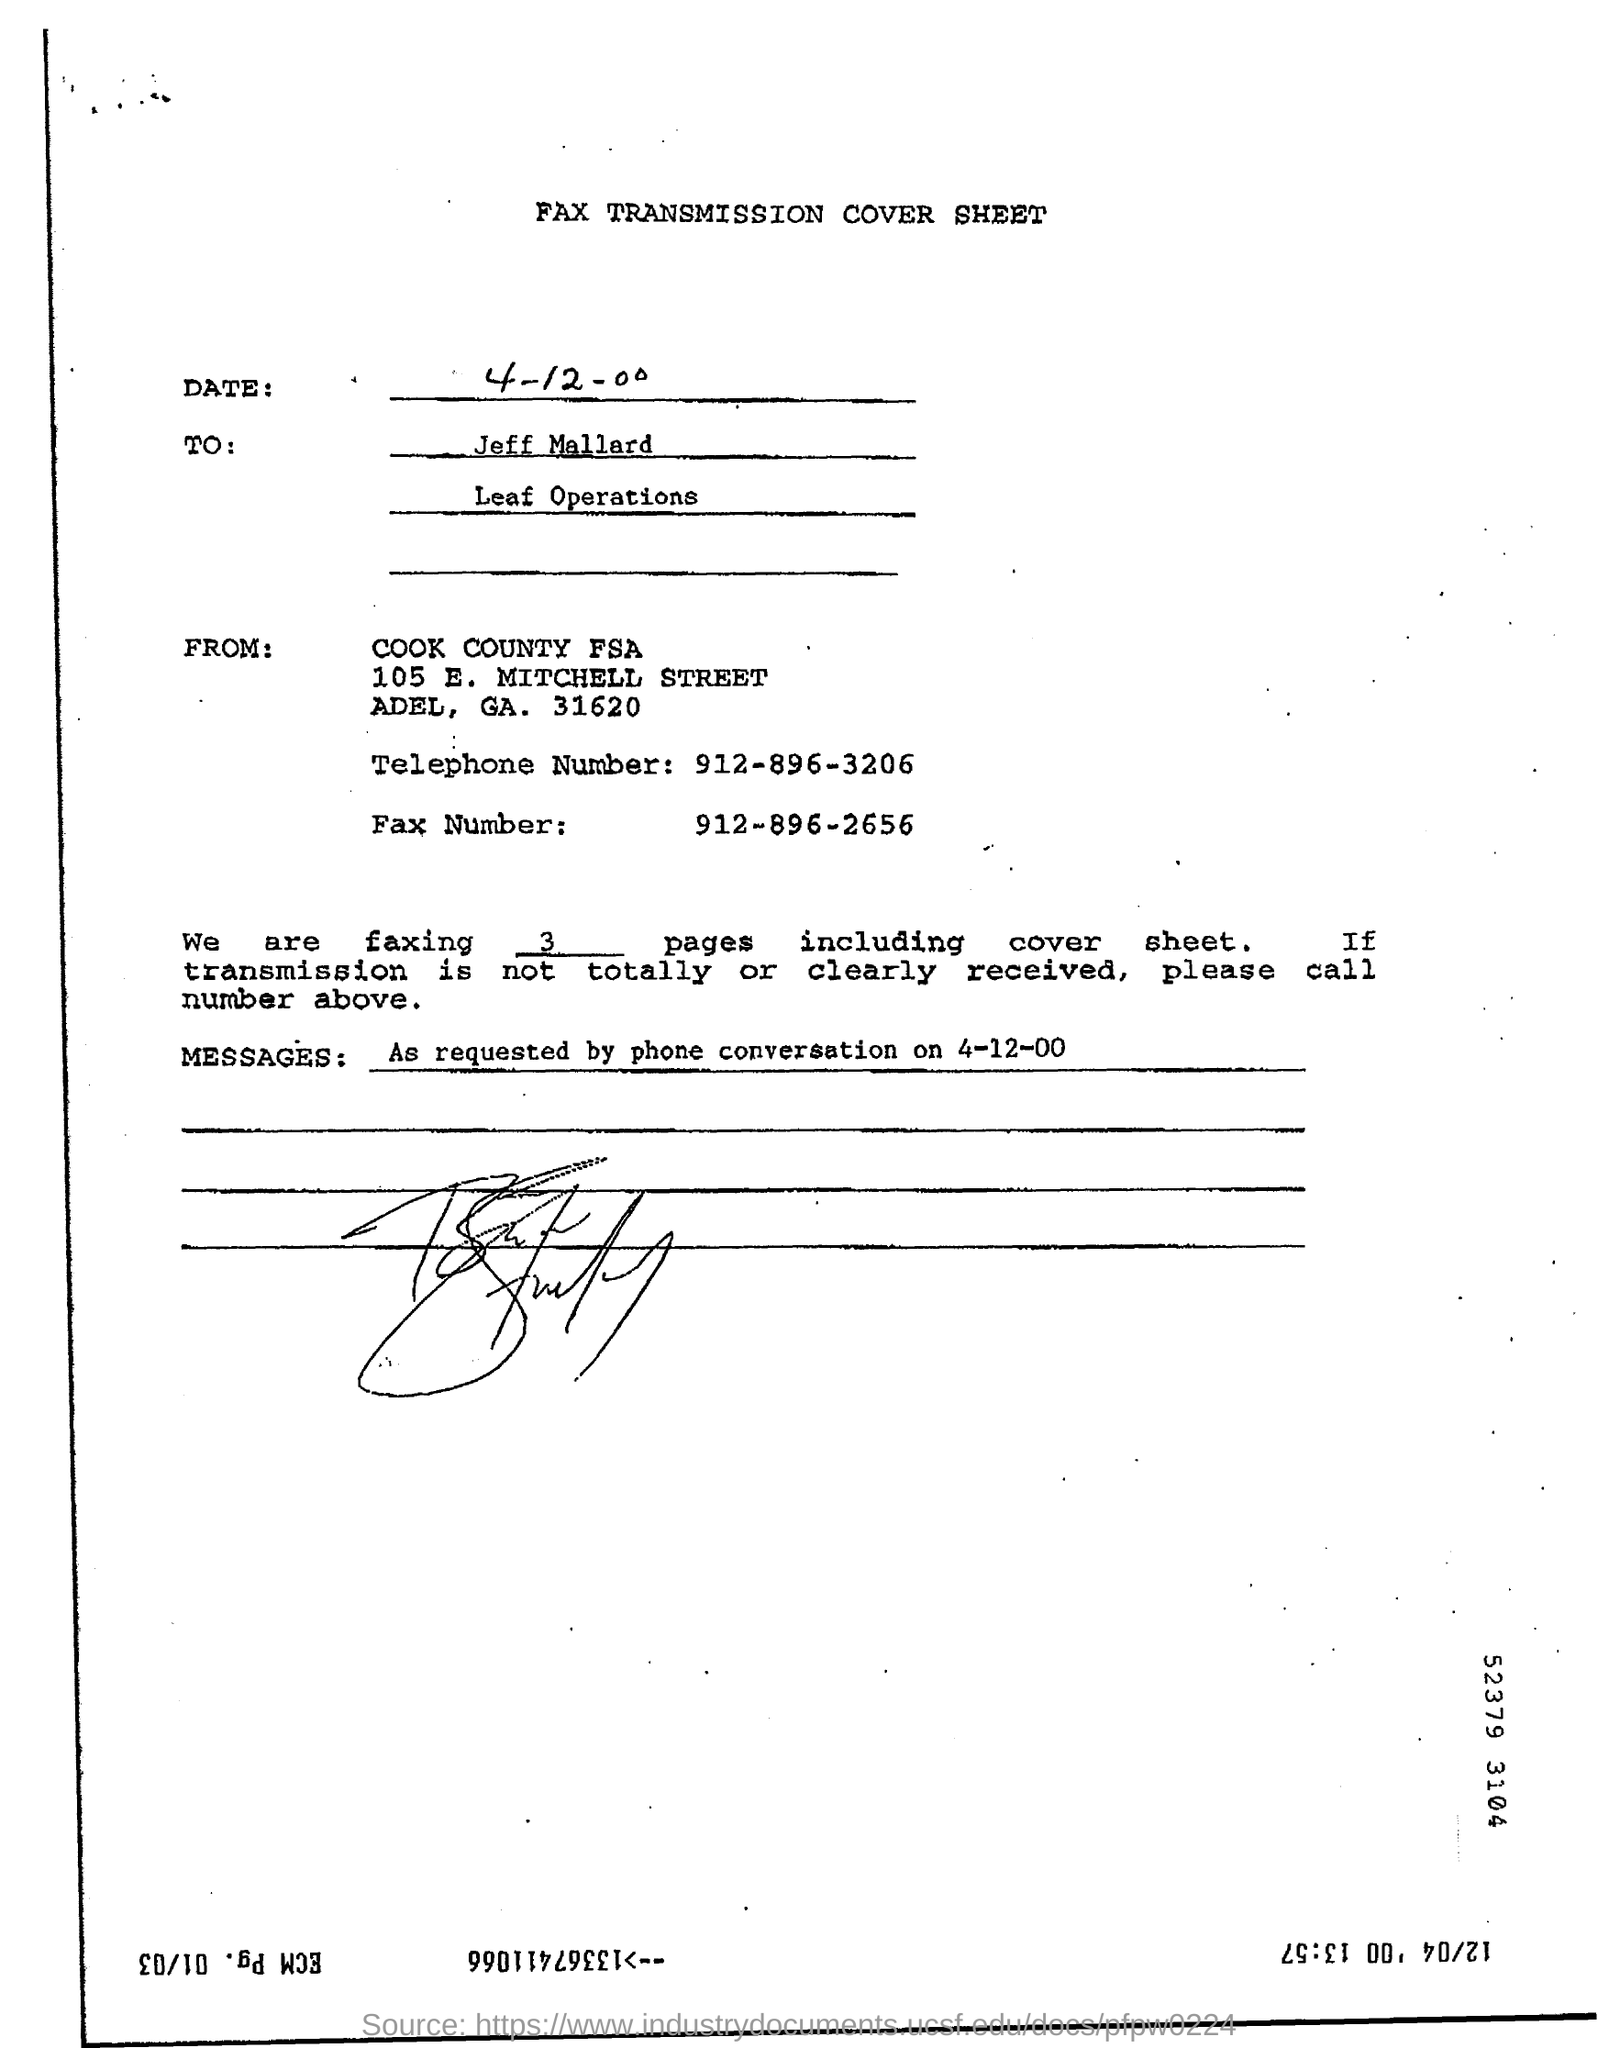List a handful of essential elements in this visual. I am faxing three pages. The telephone number mentioned in the document is 912-896-3206. The fax number mentioned in the document is 912-896-2656. 